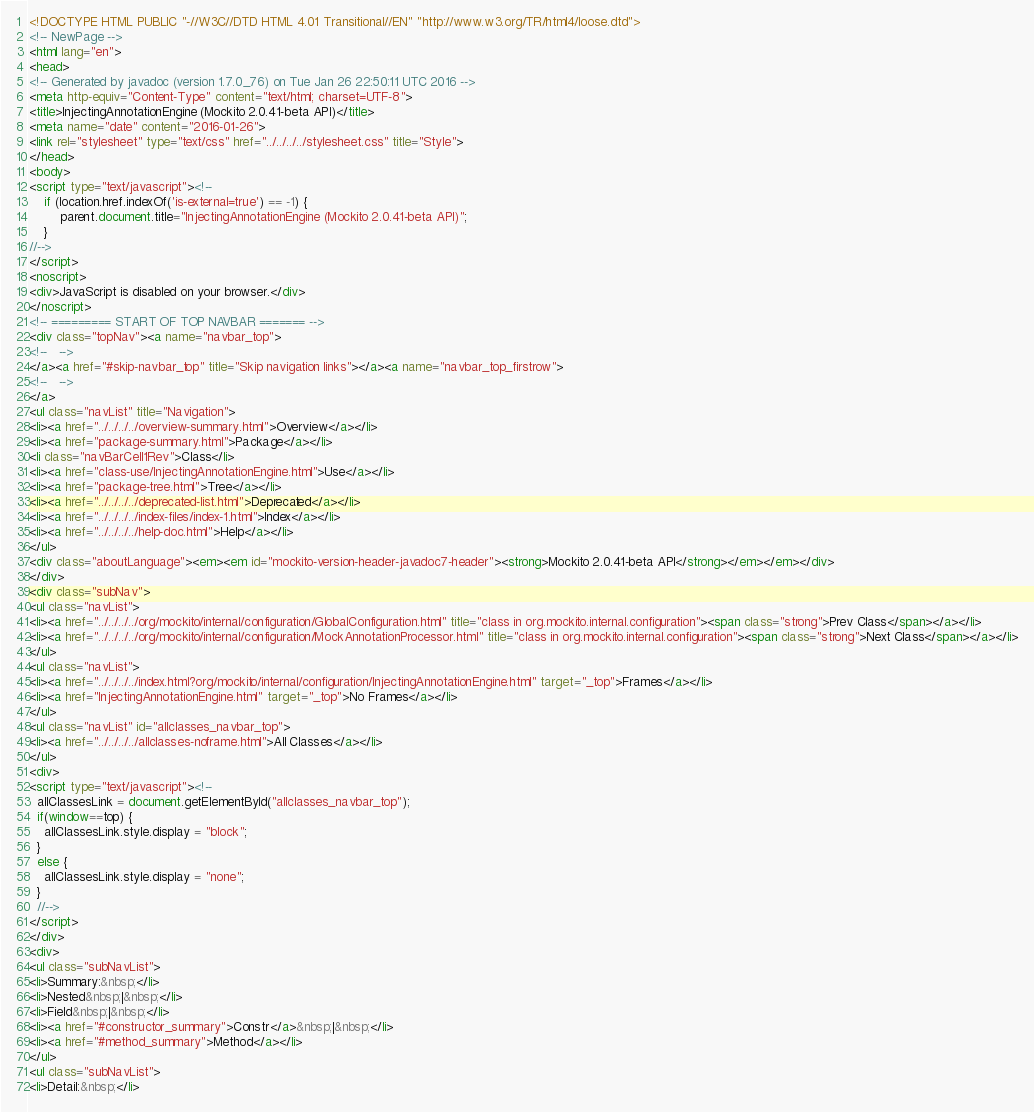Convert code to text. <code><loc_0><loc_0><loc_500><loc_500><_HTML_><!DOCTYPE HTML PUBLIC "-//W3C//DTD HTML 4.01 Transitional//EN" "http://www.w3.org/TR/html4/loose.dtd">
<!-- NewPage -->
<html lang="en">
<head>
<!-- Generated by javadoc (version 1.7.0_76) on Tue Jan 26 22:50:11 UTC 2016 -->
<meta http-equiv="Content-Type" content="text/html; charset=UTF-8">
<title>InjectingAnnotationEngine (Mockito 2.0.41-beta API)</title>
<meta name="date" content="2016-01-26">
<link rel="stylesheet" type="text/css" href="../../../../stylesheet.css" title="Style">
</head>
<body>
<script type="text/javascript"><!--
    if (location.href.indexOf('is-external=true') == -1) {
        parent.document.title="InjectingAnnotationEngine (Mockito 2.0.41-beta API)";
    }
//-->
</script>
<noscript>
<div>JavaScript is disabled on your browser.</div>
</noscript>
<!-- ========= START OF TOP NAVBAR ======= -->
<div class="topNav"><a name="navbar_top">
<!--   -->
</a><a href="#skip-navbar_top" title="Skip navigation links"></a><a name="navbar_top_firstrow">
<!--   -->
</a>
<ul class="navList" title="Navigation">
<li><a href="../../../../overview-summary.html">Overview</a></li>
<li><a href="package-summary.html">Package</a></li>
<li class="navBarCell1Rev">Class</li>
<li><a href="class-use/InjectingAnnotationEngine.html">Use</a></li>
<li><a href="package-tree.html">Tree</a></li>
<li><a href="../../../../deprecated-list.html">Deprecated</a></li>
<li><a href="../../../../index-files/index-1.html">Index</a></li>
<li><a href="../../../../help-doc.html">Help</a></li>
</ul>
<div class="aboutLanguage"><em><em id="mockito-version-header-javadoc7-header"><strong>Mockito 2.0.41-beta API</strong></em></em></div>
</div>
<div class="subNav">
<ul class="navList">
<li><a href="../../../../org/mockito/internal/configuration/GlobalConfiguration.html" title="class in org.mockito.internal.configuration"><span class="strong">Prev Class</span></a></li>
<li><a href="../../../../org/mockito/internal/configuration/MockAnnotationProcessor.html" title="class in org.mockito.internal.configuration"><span class="strong">Next Class</span></a></li>
</ul>
<ul class="navList">
<li><a href="../../../../index.html?org/mockito/internal/configuration/InjectingAnnotationEngine.html" target="_top">Frames</a></li>
<li><a href="InjectingAnnotationEngine.html" target="_top">No Frames</a></li>
</ul>
<ul class="navList" id="allclasses_navbar_top">
<li><a href="../../../../allclasses-noframe.html">All Classes</a></li>
</ul>
<div>
<script type="text/javascript"><!--
  allClassesLink = document.getElementById("allclasses_navbar_top");
  if(window==top) {
    allClassesLink.style.display = "block";
  }
  else {
    allClassesLink.style.display = "none";
  }
  //-->
</script>
</div>
<div>
<ul class="subNavList">
<li>Summary:&nbsp;</li>
<li>Nested&nbsp;|&nbsp;</li>
<li>Field&nbsp;|&nbsp;</li>
<li><a href="#constructor_summary">Constr</a>&nbsp;|&nbsp;</li>
<li><a href="#method_summary">Method</a></li>
</ul>
<ul class="subNavList">
<li>Detail:&nbsp;</li></code> 